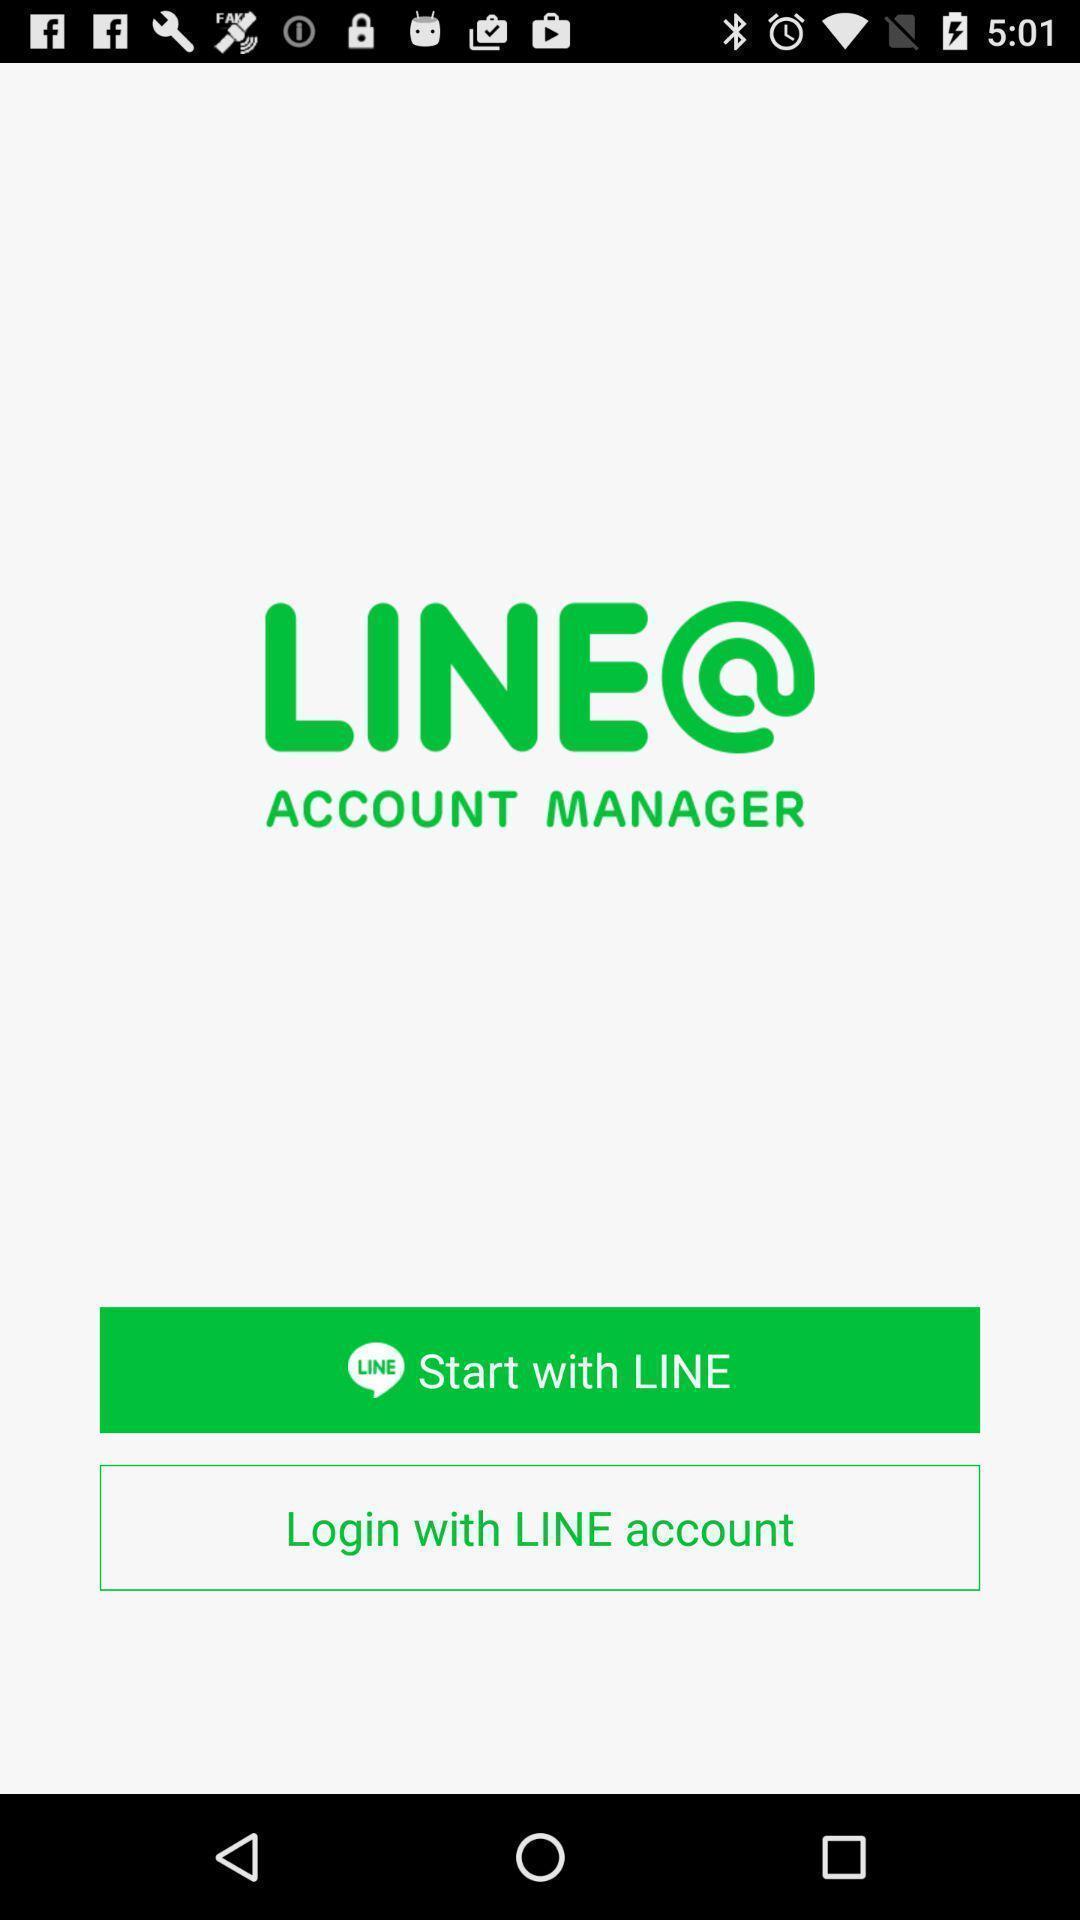Give me a narrative description of this picture. Start page or login page. 